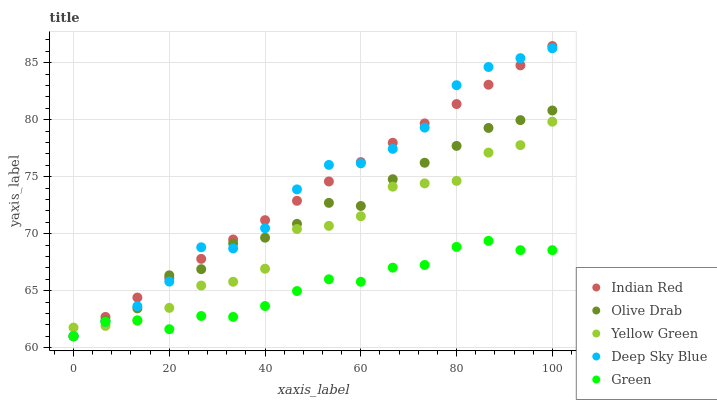Does Green have the minimum area under the curve?
Answer yes or no. Yes. Does Deep Sky Blue have the maximum area under the curve?
Answer yes or no. Yes. Does Olive Drab have the minimum area under the curve?
Answer yes or no. No. Does Olive Drab have the maximum area under the curve?
Answer yes or no. No. Is Indian Red the smoothest?
Answer yes or no. Yes. Is Yellow Green the roughest?
Answer yes or no. Yes. Is Green the smoothest?
Answer yes or no. No. Is Green the roughest?
Answer yes or no. No. Does Deep Sky Blue have the lowest value?
Answer yes or no. Yes. Does Yellow Green have the lowest value?
Answer yes or no. No. Does Indian Red have the highest value?
Answer yes or no. Yes. Does Olive Drab have the highest value?
Answer yes or no. No. Does Green intersect Indian Red?
Answer yes or no. Yes. Is Green less than Indian Red?
Answer yes or no. No. Is Green greater than Indian Red?
Answer yes or no. No. 